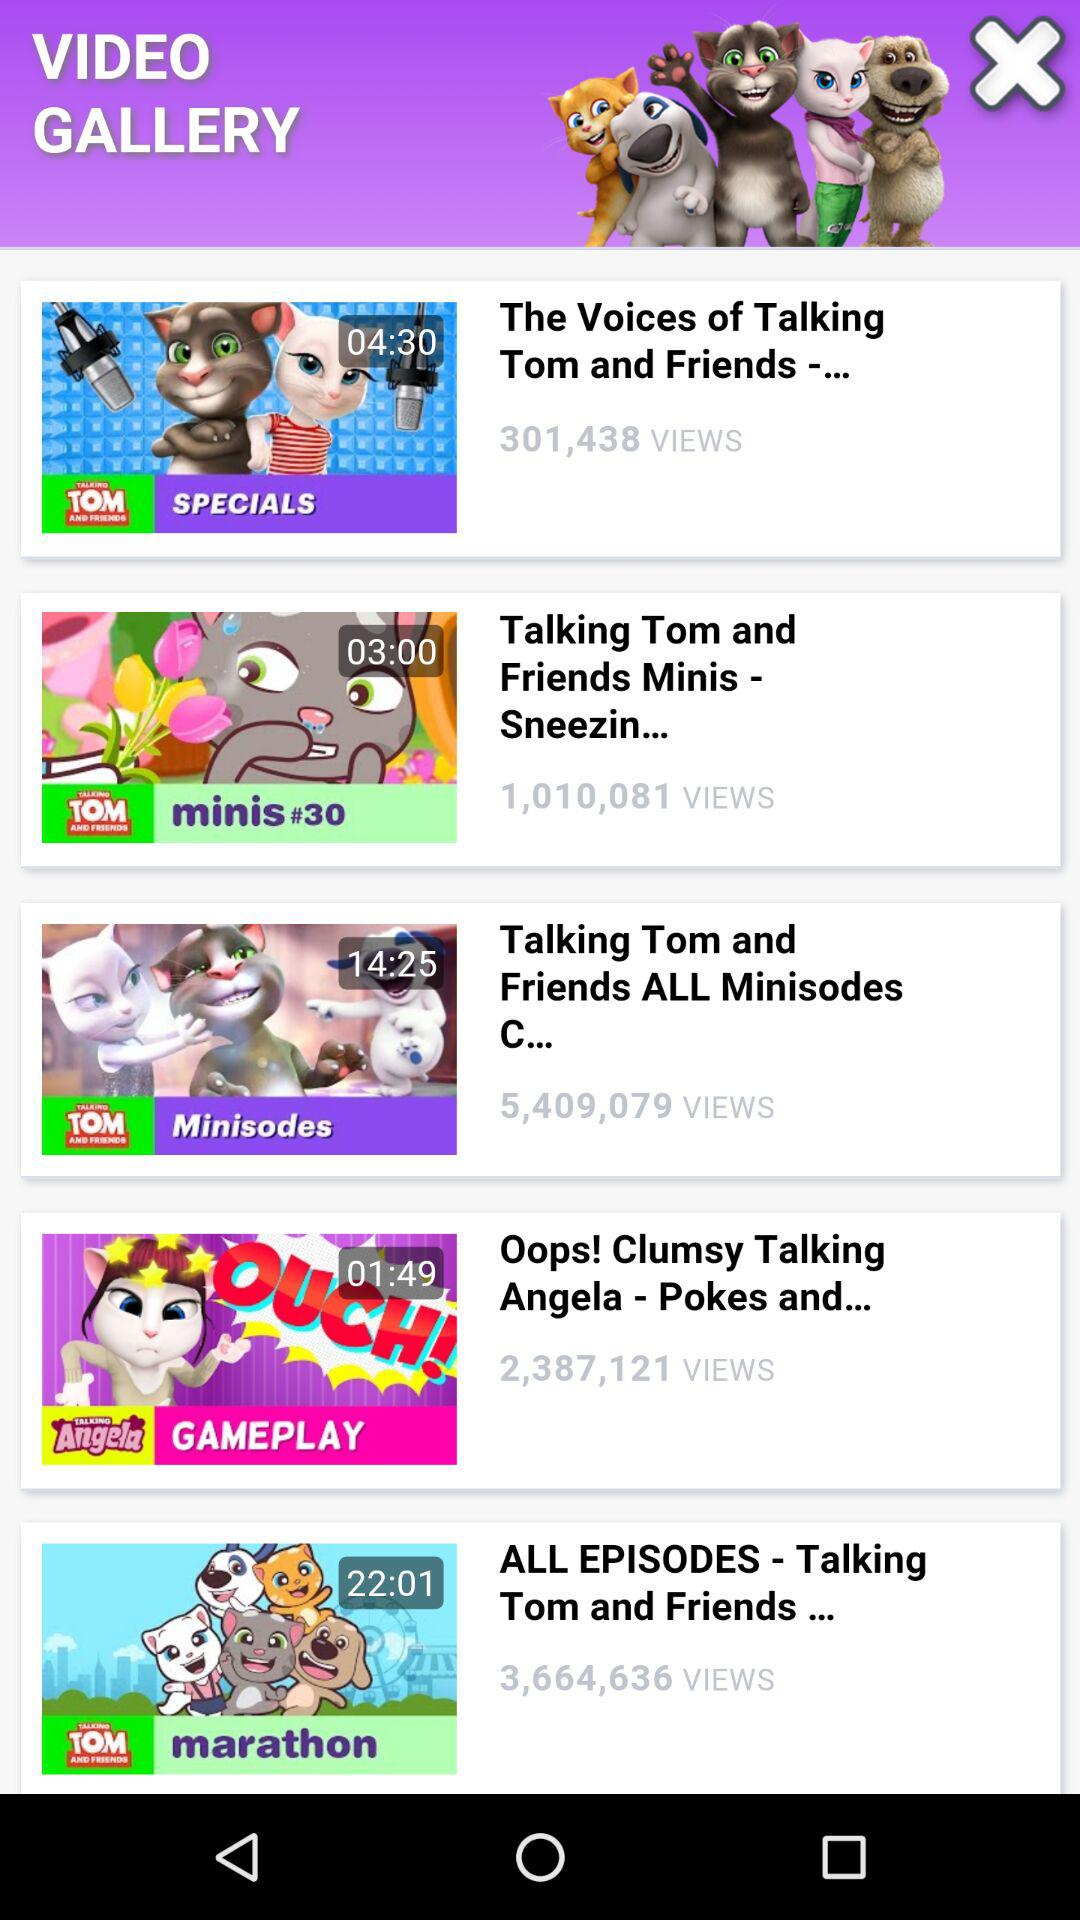How many videos have over 1M views?
Answer the question using a single word or phrase. 4 